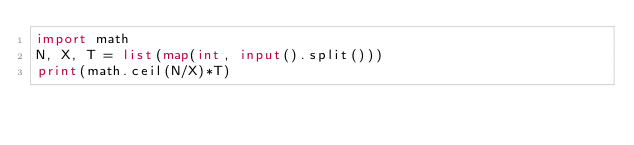<code> <loc_0><loc_0><loc_500><loc_500><_Python_>import math
N, X, T = list(map(int, input().split()))
print(math.ceil(N/X)*T)</code> 